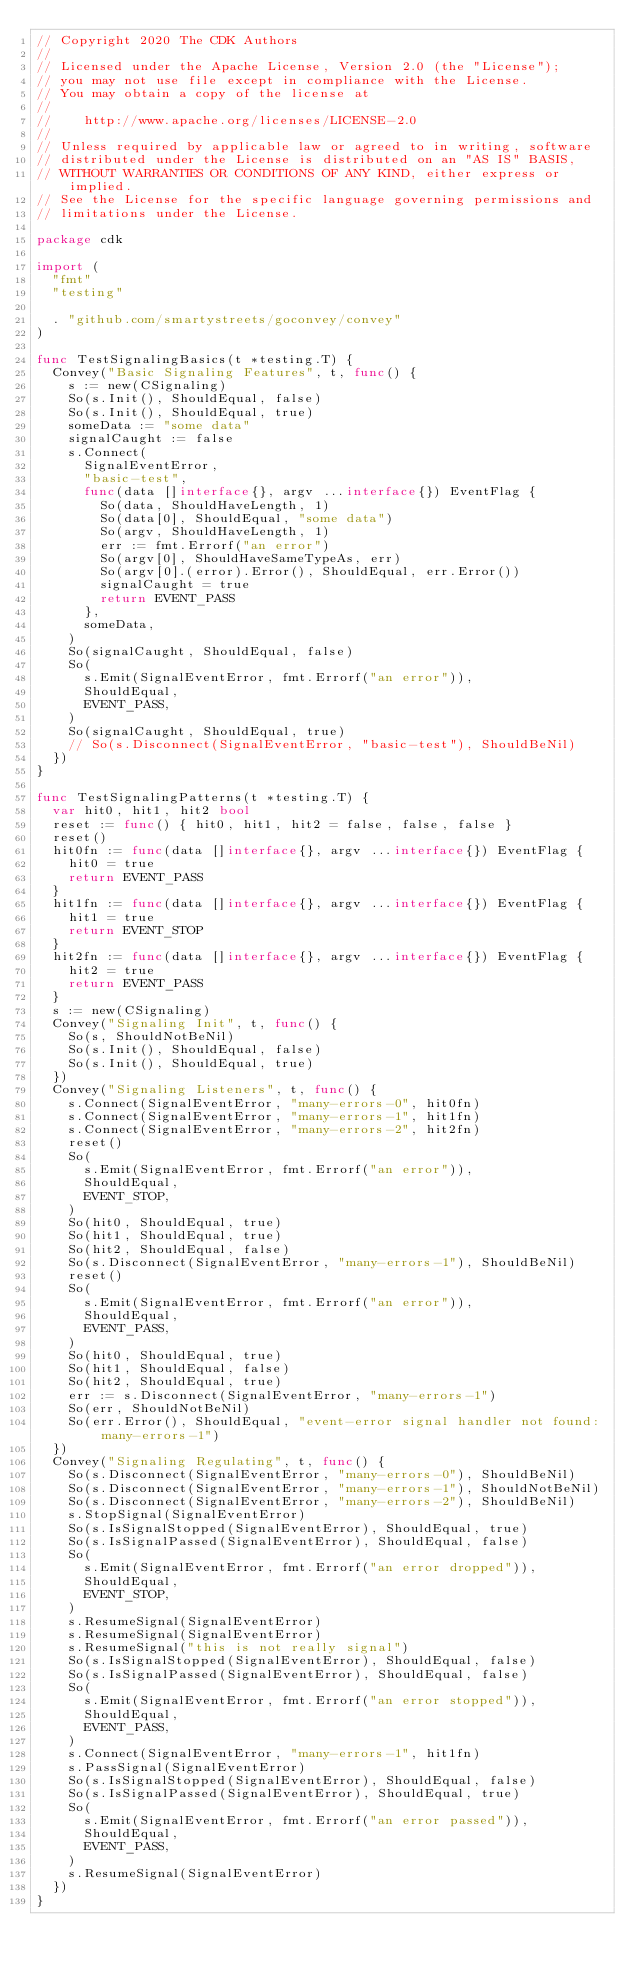<code> <loc_0><loc_0><loc_500><loc_500><_Go_>// Copyright 2020 The CDK Authors
//
// Licensed under the Apache License, Version 2.0 (the "License");
// you may not use file except in compliance with the License.
// You may obtain a copy of the license at
//
//    http://www.apache.org/licenses/LICENSE-2.0
//
// Unless required by applicable law or agreed to in writing, software
// distributed under the License is distributed on an "AS IS" BASIS,
// WITHOUT WARRANTIES OR CONDITIONS OF ANY KIND, either express or implied.
// See the License for the specific language governing permissions and
// limitations under the License.

package cdk

import (
	"fmt"
	"testing"

	. "github.com/smartystreets/goconvey/convey"
)

func TestSignalingBasics(t *testing.T) {
	Convey("Basic Signaling Features", t, func() {
		s := new(CSignaling)
		So(s.Init(), ShouldEqual, false)
		So(s.Init(), ShouldEqual, true)
		someData := "some data"
		signalCaught := false
		s.Connect(
			SignalEventError,
			"basic-test",
			func(data []interface{}, argv ...interface{}) EventFlag {
				So(data, ShouldHaveLength, 1)
				So(data[0], ShouldEqual, "some data")
				So(argv, ShouldHaveLength, 1)
				err := fmt.Errorf("an error")
				So(argv[0], ShouldHaveSameTypeAs, err)
				So(argv[0].(error).Error(), ShouldEqual, err.Error())
				signalCaught = true
				return EVENT_PASS
			},
			someData,
		)
		So(signalCaught, ShouldEqual, false)
		So(
			s.Emit(SignalEventError, fmt.Errorf("an error")),
			ShouldEqual,
			EVENT_PASS,
		)
		So(signalCaught, ShouldEqual, true)
		// So(s.Disconnect(SignalEventError, "basic-test"), ShouldBeNil)
	})
}

func TestSignalingPatterns(t *testing.T) {
	var hit0, hit1, hit2 bool
	reset := func() { hit0, hit1, hit2 = false, false, false }
	reset()
	hit0fn := func(data []interface{}, argv ...interface{}) EventFlag {
		hit0 = true
		return EVENT_PASS
	}
	hit1fn := func(data []interface{}, argv ...interface{}) EventFlag {
		hit1 = true
		return EVENT_STOP
	}
	hit2fn := func(data []interface{}, argv ...interface{}) EventFlag {
		hit2 = true
		return EVENT_PASS
	}
	s := new(CSignaling)
	Convey("Signaling Init", t, func() {
		So(s, ShouldNotBeNil)
		So(s.Init(), ShouldEqual, false)
		So(s.Init(), ShouldEqual, true)
	})
	Convey("Signaling Listeners", t, func() {
		s.Connect(SignalEventError, "many-errors-0", hit0fn)
		s.Connect(SignalEventError, "many-errors-1", hit1fn)
		s.Connect(SignalEventError, "many-errors-2", hit2fn)
		reset()
		So(
			s.Emit(SignalEventError, fmt.Errorf("an error")),
			ShouldEqual,
			EVENT_STOP,
		)
		So(hit0, ShouldEqual, true)
		So(hit1, ShouldEqual, true)
		So(hit2, ShouldEqual, false)
		So(s.Disconnect(SignalEventError, "many-errors-1"), ShouldBeNil)
		reset()
		So(
			s.Emit(SignalEventError, fmt.Errorf("an error")),
			ShouldEqual,
			EVENT_PASS,
		)
		So(hit0, ShouldEqual, true)
		So(hit1, ShouldEqual, false)
		So(hit2, ShouldEqual, true)
		err := s.Disconnect(SignalEventError, "many-errors-1")
		So(err, ShouldNotBeNil)
		So(err.Error(), ShouldEqual, "event-error signal handler not found: many-errors-1")
	})
	Convey("Signaling Regulating", t, func() {
		So(s.Disconnect(SignalEventError, "many-errors-0"), ShouldBeNil)
		So(s.Disconnect(SignalEventError, "many-errors-1"), ShouldNotBeNil)
		So(s.Disconnect(SignalEventError, "many-errors-2"), ShouldBeNil)
		s.StopSignal(SignalEventError)
		So(s.IsSignalStopped(SignalEventError), ShouldEqual, true)
		So(s.IsSignalPassed(SignalEventError), ShouldEqual, false)
		So(
			s.Emit(SignalEventError, fmt.Errorf("an error dropped")),
			ShouldEqual,
			EVENT_STOP,
		)
		s.ResumeSignal(SignalEventError)
		s.ResumeSignal(SignalEventError)
		s.ResumeSignal("this is not really signal")
		So(s.IsSignalStopped(SignalEventError), ShouldEqual, false)
		So(s.IsSignalPassed(SignalEventError), ShouldEqual, false)
		So(
			s.Emit(SignalEventError, fmt.Errorf("an error stopped")),
			ShouldEqual,
			EVENT_PASS,
		)
		s.Connect(SignalEventError, "many-errors-1", hit1fn)
		s.PassSignal(SignalEventError)
		So(s.IsSignalStopped(SignalEventError), ShouldEqual, false)
		So(s.IsSignalPassed(SignalEventError), ShouldEqual, true)
		So(
			s.Emit(SignalEventError, fmt.Errorf("an error passed")),
			ShouldEqual,
			EVENT_PASS,
		)
		s.ResumeSignal(SignalEventError)
	})
}
</code> 